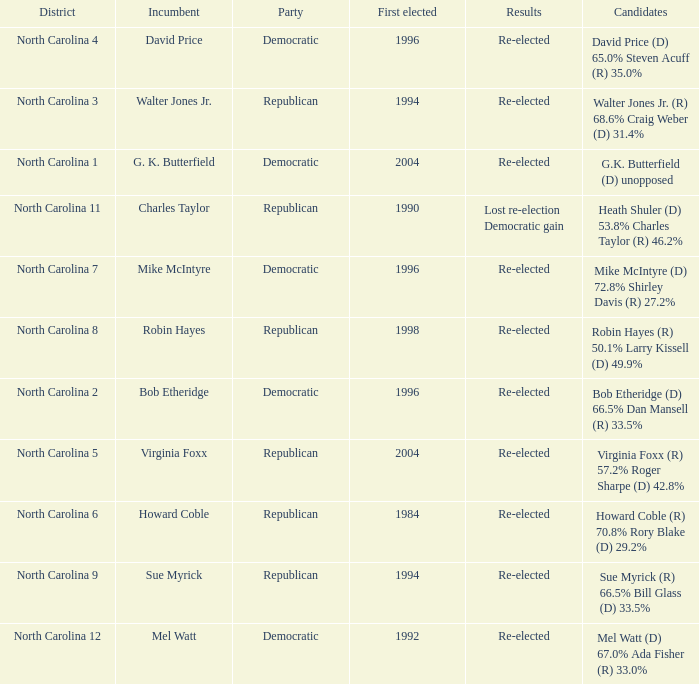Can you give me this table as a dict? {'header': ['District', 'Incumbent', 'Party', 'First elected', 'Results', 'Candidates'], 'rows': [['North Carolina 4', 'David Price', 'Democratic', '1996', 'Re-elected', 'David Price (D) 65.0% Steven Acuff (R) 35.0%'], ['North Carolina 3', 'Walter Jones Jr.', 'Republican', '1994', 'Re-elected', 'Walter Jones Jr. (R) 68.6% Craig Weber (D) 31.4%'], ['North Carolina 1', 'G. K. Butterfield', 'Democratic', '2004', 'Re-elected', 'G.K. Butterfield (D) unopposed'], ['North Carolina 11', 'Charles Taylor', 'Republican', '1990', 'Lost re-election Democratic gain', 'Heath Shuler (D) 53.8% Charles Taylor (R) 46.2%'], ['North Carolina 7', 'Mike McIntyre', 'Democratic', '1996', 'Re-elected', 'Mike McIntyre (D) 72.8% Shirley Davis (R) 27.2%'], ['North Carolina 8', 'Robin Hayes', 'Republican', '1998', 'Re-elected', 'Robin Hayes (R) 50.1% Larry Kissell (D) 49.9%'], ['North Carolina 2', 'Bob Etheridge', 'Democratic', '1996', 'Re-elected', 'Bob Etheridge (D) 66.5% Dan Mansell (R) 33.5%'], ['North Carolina 5', 'Virginia Foxx', 'Republican', '2004', 'Re-elected', 'Virginia Foxx (R) 57.2% Roger Sharpe (D) 42.8%'], ['North Carolina 6', 'Howard Coble', 'Republican', '1984', 'Re-elected', 'Howard Coble (R) 70.8% Rory Blake (D) 29.2%'], ['North Carolina 9', 'Sue Myrick', 'Republican', '1994', 'Re-elected', 'Sue Myrick (R) 66.5% Bill Glass (D) 33.5%'], ['North Carolina 12', 'Mel Watt', 'Democratic', '1992', 'Re-elected', 'Mel Watt (D) 67.0% Ada Fisher (R) 33.0%']]} How many times did Robin Hayes run? 1.0. 